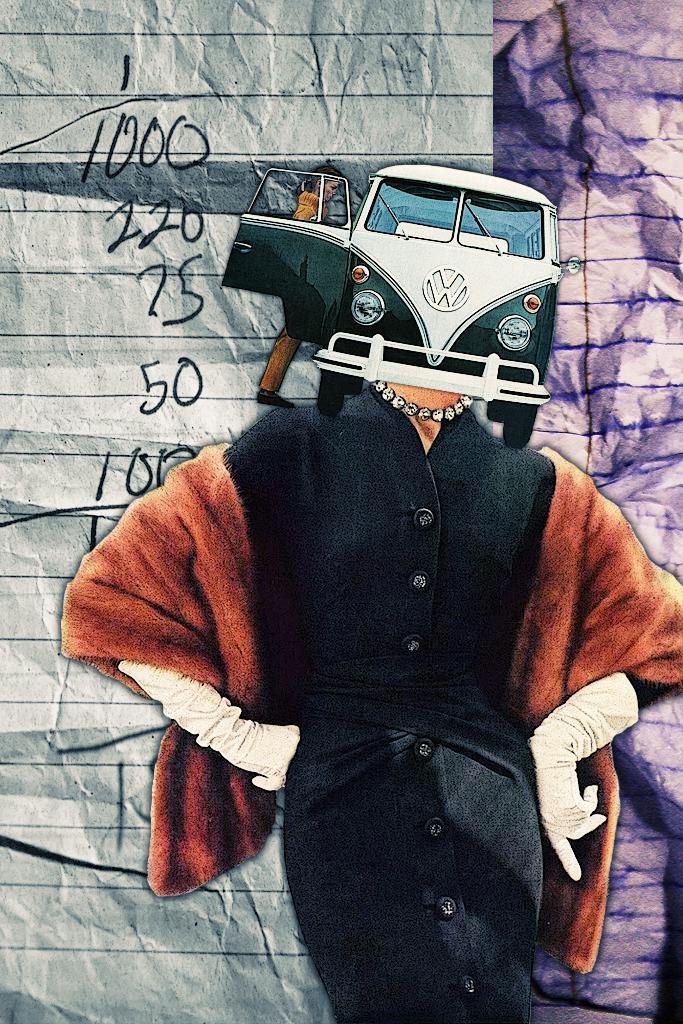Could you give a brief overview of what you see in this image? In this image I can see a person is standing , this person wore black color top. It is an edited image, at the top there is a vehicle and a person is trying to get into that. Behind this there is a paper with numbers on it. 